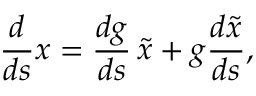Convert formula to latex. <formula><loc_0><loc_0><loc_500><loc_500>\frac { d } { d s } x = \frac { d g } { d s } \, \widetilde { x } + g \frac { d \widetilde { x } } { d s } ,</formula> 